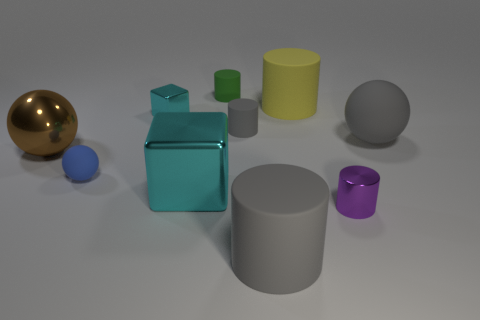How would you categorize the objects in the image based on their shapes? The objects could be categorized into spheres, cylinders, and cubes. The two spheres are the gold and dark grey ones. The cylinders are presented in three sizes and colors: green, yellow, and light grey. The cubes are represented by only the metallic cyan object, with a smaller purple cylinder suggestive of a cube but with rounded edges. Which objects seem out of place in this collection? All objects seem to be part of a deliberate collection for a composition exercise or a color and shape study. However, if we were to find an outlier, the shiny gold sphere might seem out of place due to its reflective metallic finish, which contrasts with the matte finishes of the other objects. 